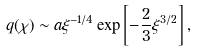Convert formula to latex. <formula><loc_0><loc_0><loc_500><loc_500>q ( \chi ) \sim a \xi ^ { - 1 / 4 } \exp \left [ - \frac { 2 } { 3 } \xi ^ { 3 / 2 } \right ] ,</formula> 